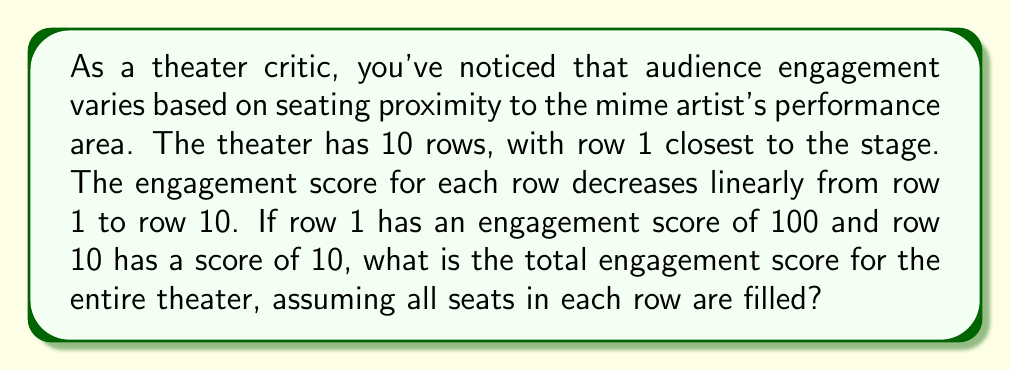Could you help me with this problem? To solve this problem, we need to:
1. Find the engagement score for each row
2. Sum up the scores for all rows

Step 1: Finding the engagement score for each row
The engagement score follows an arithmetic sequence. Let's define:
$a_1 = 100$ (first term, row 1 score)
$a_{10} = 10$ (last term, row 10 score)
$n = 10$ (number of rows)

We can find the common difference $d$ using the arithmetic sequence formula:
$$a_n = a_1 + (n-1)d$$
$$10 = 100 + (10-1)d$$
$$-90 = 9d$$
$$d = -10$$

Now we can list out the engagement scores for each row:
Row 1: 100
Row 2: 90
Row 3: 80
Row 4: 70
Row 5: 60
Row 6: 50
Row 7: 40
Row 8: 30
Row 9: 20
Row 10: 10

Step 2: Summing up the scores
We can use the arithmetic sequence sum formula:
$$S_n = \frac{n}{2}(a_1 + a_n)$$
Where:
$S_n$ is the sum of the sequence
$n$ is the number of terms
$a_1$ is the first term
$a_n$ is the last term

Plugging in our values:
$$S_{10} = \frac{10}{2}(100 + 10)$$
$$S_{10} = 5(110)$$
$$S_{10} = 550$$

Therefore, the total engagement score for the entire theater is 550.
Answer: 550 